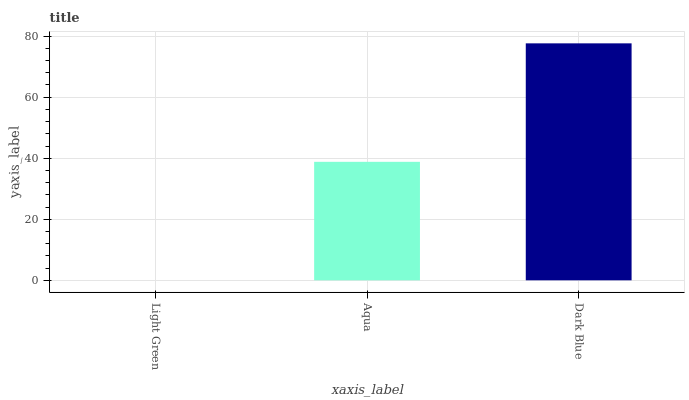Is Light Green the minimum?
Answer yes or no. Yes. Is Dark Blue the maximum?
Answer yes or no. Yes. Is Aqua the minimum?
Answer yes or no. No. Is Aqua the maximum?
Answer yes or no. No. Is Aqua greater than Light Green?
Answer yes or no. Yes. Is Light Green less than Aqua?
Answer yes or no. Yes. Is Light Green greater than Aqua?
Answer yes or no. No. Is Aqua less than Light Green?
Answer yes or no. No. Is Aqua the high median?
Answer yes or no. Yes. Is Aqua the low median?
Answer yes or no. Yes. Is Light Green the high median?
Answer yes or no. No. Is Light Green the low median?
Answer yes or no. No. 